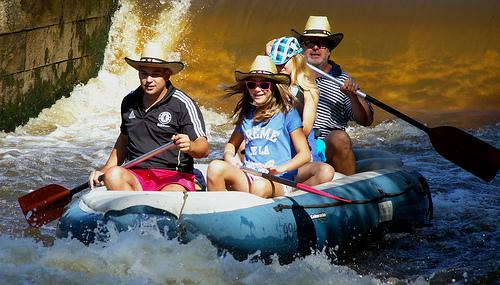Question: what are the people doing?
Choices:
A. Playing soccer.
B. Jogging.
C. Sewing.
D. Rafting.
Answer with the letter. Answer: D Question: who is in the boat?
Choices:
A. A fisherman.
B. Two girls and two guys.
C. A man and his dog.
D. An old lady.
Answer with the letter. Answer: B Question: when was the photo taken?
Choices:
A. Dawn.
B. Midnight.
C. Evening.
D. Afternoon.
Answer with the letter. Answer: D 